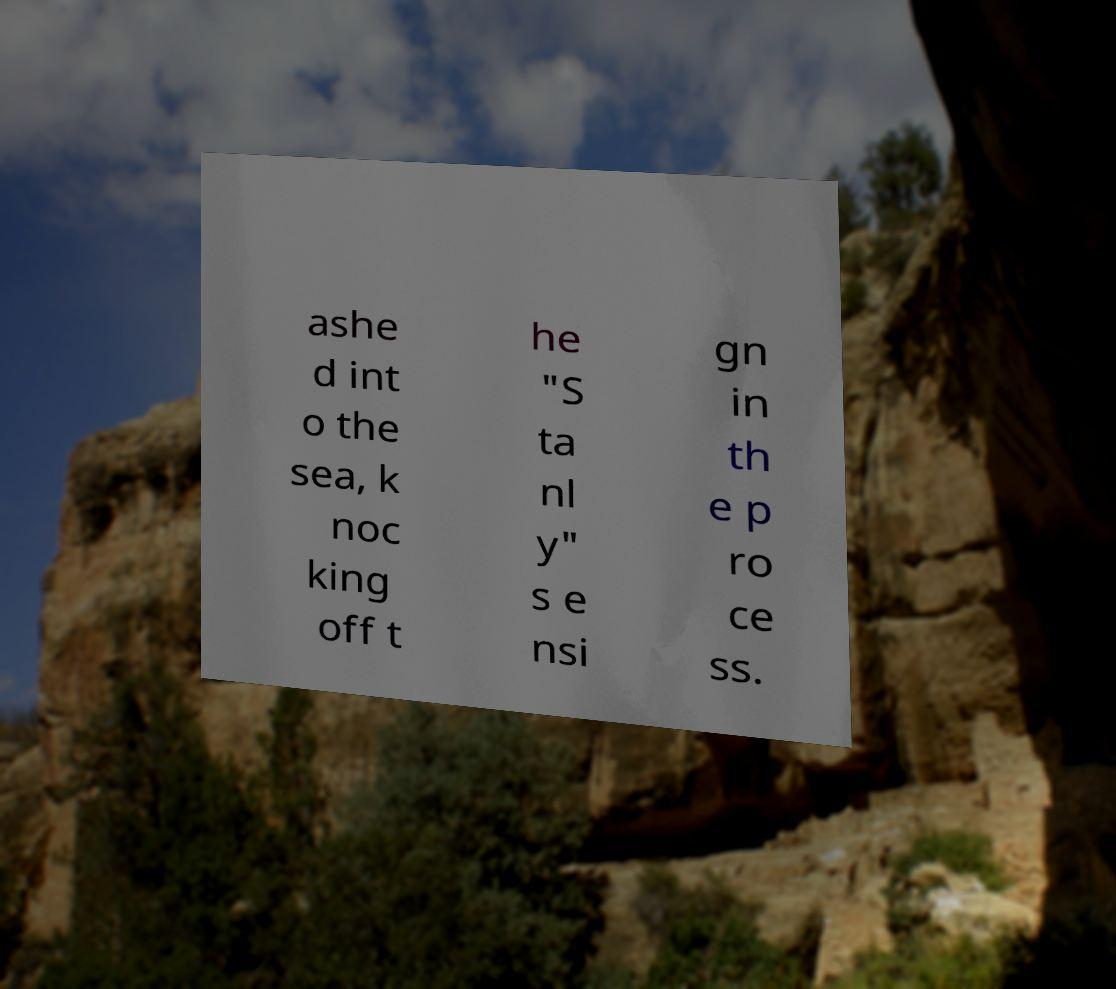Could you extract and type out the text from this image? ashe d int o the sea, k noc king off t he "S ta nl y" s e nsi gn in th e p ro ce ss. 